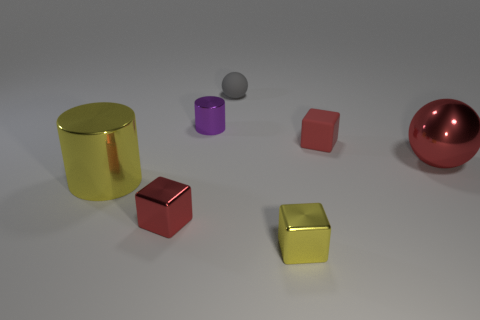Subtract all red blocks. How many blocks are left? 1 Subtract all yellow cylinders. How many red blocks are left? 2 Add 2 yellow metallic cylinders. How many objects exist? 9 Subtract all cylinders. How many objects are left? 5 Subtract all green blocks. Subtract all green spheres. How many blocks are left? 3 Subtract all tiny cyan matte things. Subtract all tiny spheres. How many objects are left? 6 Add 5 large red metallic balls. How many large red metallic balls are left? 6 Add 5 big metal balls. How many big metal balls exist? 6 Subtract 0 blue cylinders. How many objects are left? 7 